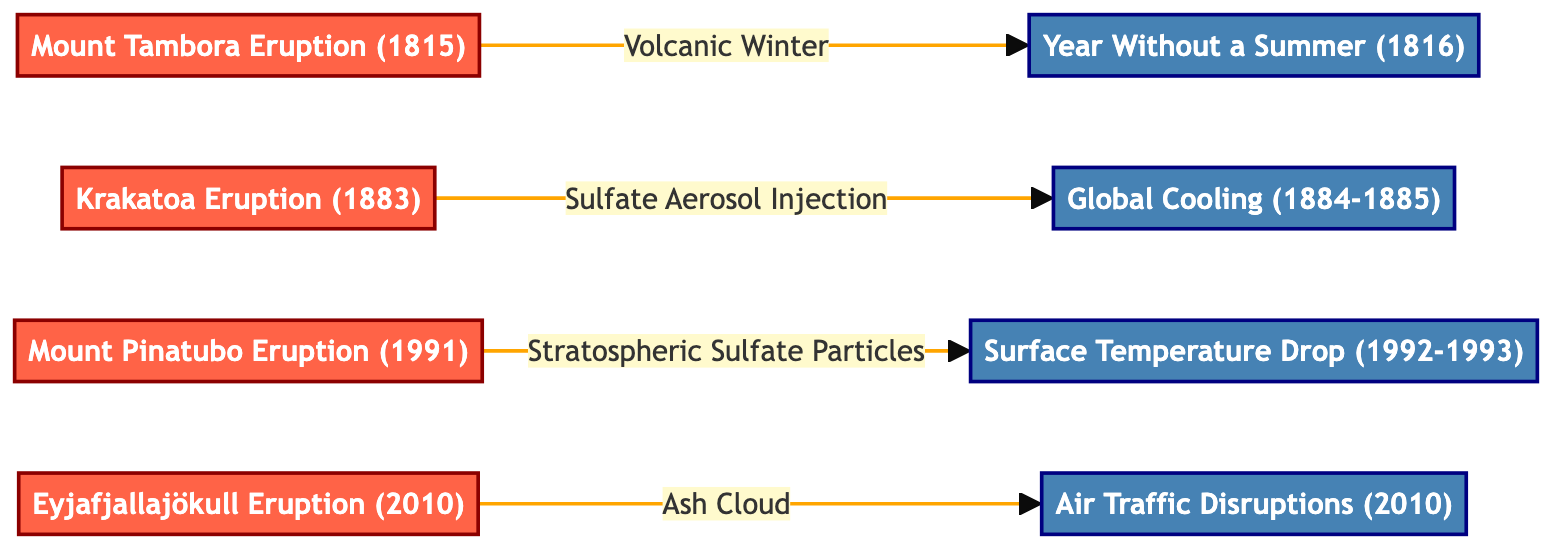What are the notable volcanic eruptions listed in the diagram? The diagram displays four notable volcanic eruptions: Mount Tambora (1815), Krakatoa (1883), Mount Pinatubo (1991), and Eyjafjallajökull (2010).
Answer: Mount Tambora, Krakatoa, Mount Pinatubo, Eyjafjallajökull How many climatic effects are associated with the eruptions in the diagram? The diagram has four climatic effects listed: Year Without a Summer (1816), Global Cooling (1884-1885), Surface Temperature Drop (1992-1993), and Air Traffic Disruptions (2010).
Answer: Four Which eruption is connected to the "Year Without a Summer"? The "Year Without a Summer" is directly connected to the Mount Tambora Eruption (1815) in the diagram.
Answer: Mount Tambora Eruption (1815) What type of relationship connects the Mount Pinatubo Eruption to its climatic effect? The Mount Pinatubo Eruption (1991) is connected to its climatic effect, "Surface Temperature Drop (1992-1993)," through the relationship labeled "Stratospheric Sulfate Particles."
Answer: Stratospheric Sulfate Particles Which eruption caused air traffic disruptions? The Eyjafjallajökull Eruption (2010) is the eruption that caused air traffic disruptions as noted in the diagram.
Answer: Eyjafjallajökull Eruption (2010) What is the common type of climatic impact noted for all eruptions? All eruptions are associated with climatic impacts that result in cooling or disruptions, such as a volcanic winter or global cooling effects.
Answer: Cooling Which eruption showed effects in the year following the event? The Mount Tambora Eruption (1815) had an effect, "Year Without a Summer," that occurred in the following year, 1816.
Answer: Mount Tambora Eruption (1815) How many nodes are found in the diagram? The diagram consists of eight total nodes, including both eruptions and their associated climatic effects.
Answer: Eight What event was caused by the Krakatoa Eruption? The Global Cooling (1884-1885) was caused by the Krakatoa Eruption (1883) as illustrated in the diagram.
Answer: Global Cooling (1884-1885) 